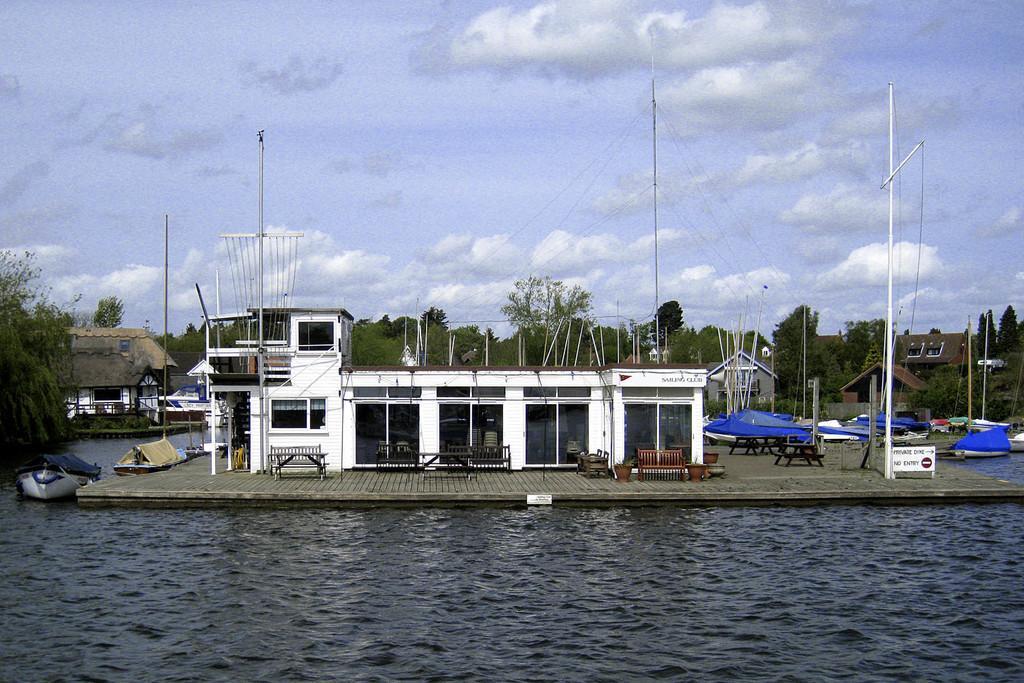Can you describe this image briefly? In this image there is water. There are boats. There are houses. There are chairs. There are trees in the background. There are poles. 